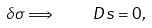<formula> <loc_0><loc_0><loc_500><loc_500>\delta \sigma \Longrightarrow \quad D s = 0 ,</formula> 